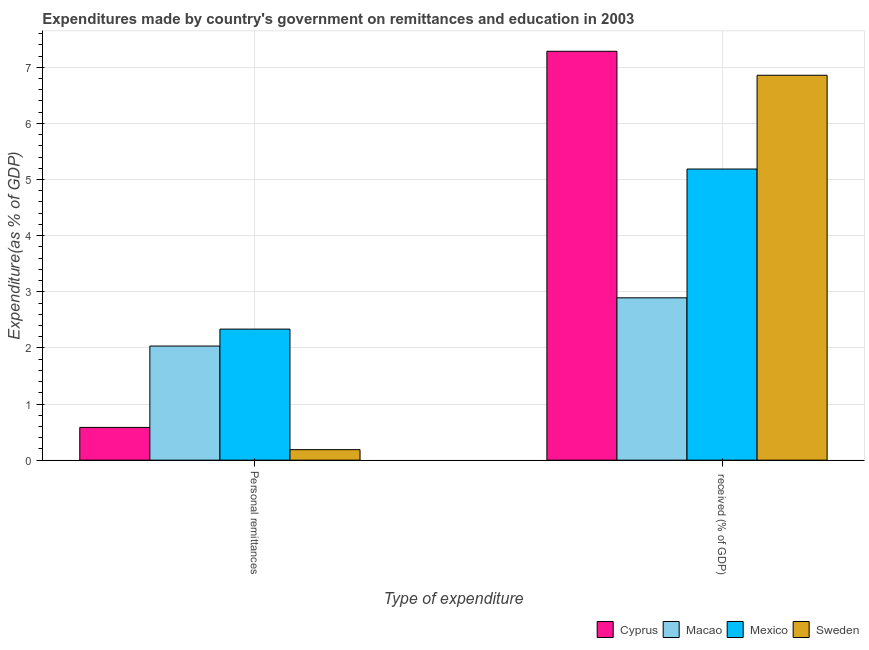Are the number of bars on each tick of the X-axis equal?
Provide a succinct answer. Yes. How many bars are there on the 1st tick from the left?
Keep it short and to the point. 4. How many bars are there on the 2nd tick from the right?
Offer a terse response. 4. What is the label of the 2nd group of bars from the left?
Ensure brevity in your answer.   received (% of GDP). What is the expenditure in personal remittances in Macao?
Offer a terse response. 2.03. Across all countries, what is the maximum expenditure in personal remittances?
Provide a short and direct response. 2.33. Across all countries, what is the minimum expenditure in education?
Provide a succinct answer. 2.89. In which country was the expenditure in education maximum?
Your response must be concise. Cyprus. In which country was the expenditure in education minimum?
Your answer should be very brief. Macao. What is the total expenditure in personal remittances in the graph?
Ensure brevity in your answer.  5.14. What is the difference between the expenditure in education in Sweden and that in Mexico?
Provide a short and direct response. 1.67. What is the difference between the expenditure in education in Macao and the expenditure in personal remittances in Sweden?
Your response must be concise. 2.71. What is the average expenditure in personal remittances per country?
Offer a terse response. 1.28. What is the difference between the expenditure in personal remittances and expenditure in education in Cyprus?
Ensure brevity in your answer.  -6.7. What is the ratio of the expenditure in personal remittances in Mexico to that in Sweden?
Your answer should be compact. 12.47. Is the expenditure in personal remittances in Sweden less than that in Mexico?
Make the answer very short. Yes. What does the 1st bar from the left in Personal remittances represents?
Offer a very short reply. Cyprus. What does the 4th bar from the right in Personal remittances represents?
Your answer should be compact. Cyprus. How many bars are there?
Give a very brief answer. 8. Are the values on the major ticks of Y-axis written in scientific E-notation?
Provide a succinct answer. No. Does the graph contain grids?
Your answer should be compact. Yes. How many legend labels are there?
Offer a terse response. 4. What is the title of the graph?
Provide a succinct answer. Expenditures made by country's government on remittances and education in 2003. Does "Equatorial Guinea" appear as one of the legend labels in the graph?
Give a very brief answer. No. What is the label or title of the X-axis?
Ensure brevity in your answer.  Type of expenditure. What is the label or title of the Y-axis?
Keep it short and to the point. Expenditure(as % of GDP). What is the Expenditure(as % of GDP) of Cyprus in Personal remittances?
Provide a short and direct response. 0.58. What is the Expenditure(as % of GDP) of Macao in Personal remittances?
Keep it short and to the point. 2.03. What is the Expenditure(as % of GDP) in Mexico in Personal remittances?
Provide a succinct answer. 2.33. What is the Expenditure(as % of GDP) in Sweden in Personal remittances?
Offer a very short reply. 0.19. What is the Expenditure(as % of GDP) of Cyprus in  received (% of GDP)?
Your answer should be very brief. 7.29. What is the Expenditure(as % of GDP) of Macao in  received (% of GDP)?
Ensure brevity in your answer.  2.89. What is the Expenditure(as % of GDP) of Mexico in  received (% of GDP)?
Offer a terse response. 5.19. What is the Expenditure(as % of GDP) of Sweden in  received (% of GDP)?
Ensure brevity in your answer.  6.86. Across all Type of expenditure, what is the maximum Expenditure(as % of GDP) of Cyprus?
Your answer should be very brief. 7.29. Across all Type of expenditure, what is the maximum Expenditure(as % of GDP) in Macao?
Offer a very short reply. 2.89. Across all Type of expenditure, what is the maximum Expenditure(as % of GDP) in Mexico?
Offer a very short reply. 5.19. Across all Type of expenditure, what is the maximum Expenditure(as % of GDP) of Sweden?
Your answer should be compact. 6.86. Across all Type of expenditure, what is the minimum Expenditure(as % of GDP) of Cyprus?
Make the answer very short. 0.58. Across all Type of expenditure, what is the minimum Expenditure(as % of GDP) of Macao?
Keep it short and to the point. 2.03. Across all Type of expenditure, what is the minimum Expenditure(as % of GDP) in Mexico?
Make the answer very short. 2.33. Across all Type of expenditure, what is the minimum Expenditure(as % of GDP) in Sweden?
Your answer should be compact. 0.19. What is the total Expenditure(as % of GDP) in Cyprus in the graph?
Make the answer very short. 7.87. What is the total Expenditure(as % of GDP) of Macao in the graph?
Provide a short and direct response. 4.93. What is the total Expenditure(as % of GDP) in Mexico in the graph?
Make the answer very short. 7.52. What is the total Expenditure(as % of GDP) of Sweden in the graph?
Provide a succinct answer. 7.04. What is the difference between the Expenditure(as % of GDP) of Cyprus in Personal remittances and that in  received (% of GDP)?
Keep it short and to the point. -6.7. What is the difference between the Expenditure(as % of GDP) in Macao in Personal remittances and that in  received (% of GDP)?
Offer a very short reply. -0.86. What is the difference between the Expenditure(as % of GDP) of Mexico in Personal remittances and that in  received (% of GDP)?
Give a very brief answer. -2.85. What is the difference between the Expenditure(as % of GDP) of Sweden in Personal remittances and that in  received (% of GDP)?
Offer a very short reply. -6.67. What is the difference between the Expenditure(as % of GDP) in Cyprus in Personal remittances and the Expenditure(as % of GDP) in Macao in  received (% of GDP)?
Offer a terse response. -2.31. What is the difference between the Expenditure(as % of GDP) in Cyprus in Personal remittances and the Expenditure(as % of GDP) in Mexico in  received (% of GDP)?
Give a very brief answer. -4.6. What is the difference between the Expenditure(as % of GDP) of Cyprus in Personal remittances and the Expenditure(as % of GDP) of Sweden in  received (% of GDP)?
Offer a terse response. -6.27. What is the difference between the Expenditure(as % of GDP) of Macao in Personal remittances and the Expenditure(as % of GDP) of Mexico in  received (% of GDP)?
Keep it short and to the point. -3.15. What is the difference between the Expenditure(as % of GDP) in Macao in Personal remittances and the Expenditure(as % of GDP) in Sweden in  received (% of GDP)?
Your answer should be very brief. -4.82. What is the difference between the Expenditure(as % of GDP) of Mexico in Personal remittances and the Expenditure(as % of GDP) of Sweden in  received (% of GDP)?
Your answer should be very brief. -4.52. What is the average Expenditure(as % of GDP) of Cyprus per Type of expenditure?
Make the answer very short. 3.93. What is the average Expenditure(as % of GDP) of Macao per Type of expenditure?
Provide a short and direct response. 2.46. What is the average Expenditure(as % of GDP) in Mexico per Type of expenditure?
Make the answer very short. 3.76. What is the average Expenditure(as % of GDP) of Sweden per Type of expenditure?
Offer a terse response. 3.52. What is the difference between the Expenditure(as % of GDP) of Cyprus and Expenditure(as % of GDP) of Macao in Personal remittances?
Give a very brief answer. -1.45. What is the difference between the Expenditure(as % of GDP) in Cyprus and Expenditure(as % of GDP) in Mexico in Personal remittances?
Your response must be concise. -1.75. What is the difference between the Expenditure(as % of GDP) in Cyprus and Expenditure(as % of GDP) in Sweden in Personal remittances?
Ensure brevity in your answer.  0.4. What is the difference between the Expenditure(as % of GDP) in Macao and Expenditure(as % of GDP) in Mexico in Personal remittances?
Your answer should be very brief. -0.3. What is the difference between the Expenditure(as % of GDP) of Macao and Expenditure(as % of GDP) of Sweden in Personal remittances?
Ensure brevity in your answer.  1.85. What is the difference between the Expenditure(as % of GDP) of Mexico and Expenditure(as % of GDP) of Sweden in Personal remittances?
Your response must be concise. 2.15. What is the difference between the Expenditure(as % of GDP) of Cyprus and Expenditure(as % of GDP) of Macao in  received (% of GDP)?
Ensure brevity in your answer.  4.39. What is the difference between the Expenditure(as % of GDP) in Cyprus and Expenditure(as % of GDP) in Mexico in  received (% of GDP)?
Your answer should be very brief. 2.1. What is the difference between the Expenditure(as % of GDP) in Cyprus and Expenditure(as % of GDP) in Sweden in  received (% of GDP)?
Give a very brief answer. 0.43. What is the difference between the Expenditure(as % of GDP) of Macao and Expenditure(as % of GDP) of Mexico in  received (% of GDP)?
Ensure brevity in your answer.  -2.29. What is the difference between the Expenditure(as % of GDP) of Macao and Expenditure(as % of GDP) of Sweden in  received (% of GDP)?
Provide a short and direct response. -3.97. What is the difference between the Expenditure(as % of GDP) in Mexico and Expenditure(as % of GDP) in Sweden in  received (% of GDP)?
Offer a very short reply. -1.67. What is the ratio of the Expenditure(as % of GDP) of Cyprus in Personal remittances to that in  received (% of GDP)?
Give a very brief answer. 0.08. What is the ratio of the Expenditure(as % of GDP) in Macao in Personal remittances to that in  received (% of GDP)?
Offer a very short reply. 0.7. What is the ratio of the Expenditure(as % of GDP) in Mexico in Personal remittances to that in  received (% of GDP)?
Ensure brevity in your answer.  0.45. What is the ratio of the Expenditure(as % of GDP) in Sweden in Personal remittances to that in  received (% of GDP)?
Your response must be concise. 0.03. What is the difference between the highest and the second highest Expenditure(as % of GDP) of Cyprus?
Give a very brief answer. 6.7. What is the difference between the highest and the second highest Expenditure(as % of GDP) of Macao?
Provide a short and direct response. 0.86. What is the difference between the highest and the second highest Expenditure(as % of GDP) in Mexico?
Give a very brief answer. 2.85. What is the difference between the highest and the second highest Expenditure(as % of GDP) of Sweden?
Offer a very short reply. 6.67. What is the difference between the highest and the lowest Expenditure(as % of GDP) of Cyprus?
Keep it short and to the point. 6.7. What is the difference between the highest and the lowest Expenditure(as % of GDP) of Macao?
Your answer should be very brief. 0.86. What is the difference between the highest and the lowest Expenditure(as % of GDP) in Mexico?
Offer a terse response. 2.85. What is the difference between the highest and the lowest Expenditure(as % of GDP) of Sweden?
Your answer should be very brief. 6.67. 